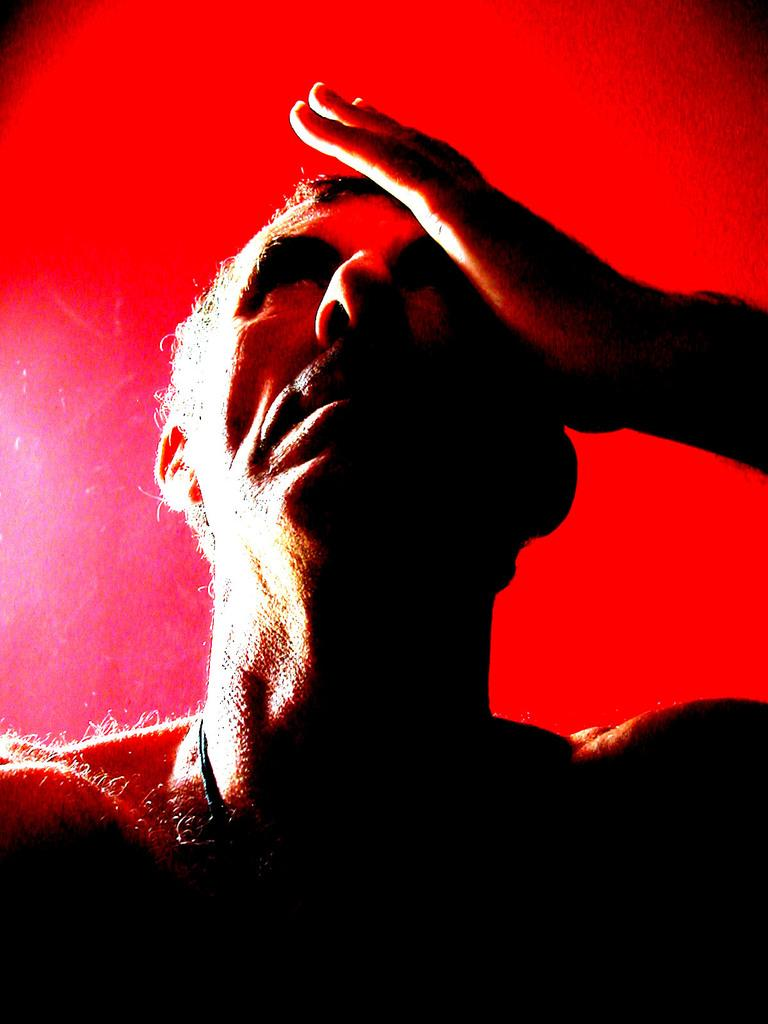What is the main subject of the image? There is a person in the image. What is the person in the image doing? The person has their hand on their face. What type of salt can be seen being used to reduce pollution in the image? There is no salt or reference to pollution present in the image; it features a person with their hand on their face. 